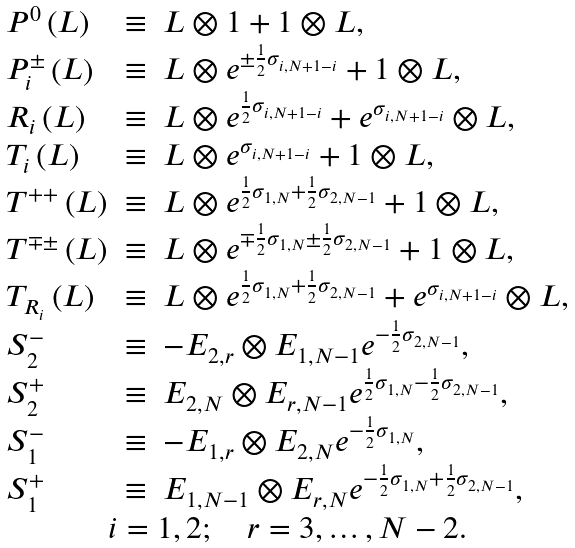Convert formula to latex. <formula><loc_0><loc_0><loc_500><loc_500>\begin{array} { c } \begin{array} { l l l } P ^ { 0 } \left ( L \right ) & \equiv & L \otimes 1 + 1 \otimes L , \\ P _ { i } ^ { \pm } \left ( L \right ) & \equiv & L \otimes e ^ { \pm \frac { 1 } { 2 } \sigma _ { i , N + 1 - i } } + 1 \otimes L , \\ R _ { i } \left ( L \right ) & \equiv & L \otimes e ^ { \frac { 1 } { 2 } \sigma _ { i , N + 1 - i } } + e ^ { \sigma _ { i , N + 1 - i } } \otimes L , \\ T _ { i } \left ( L \right ) & \equiv & L \otimes e ^ { \sigma _ { i , N + 1 - i } } + 1 \otimes L , \\ T ^ { + + } \left ( L \right ) & \equiv & L \otimes e ^ { \frac { 1 } { 2 } \sigma _ { 1 , N } + \frac { 1 } { 2 } \sigma _ { 2 , N - 1 } } + 1 \otimes L , \\ T ^ { \mp \pm } \left ( L \right ) & \equiv & L \otimes e ^ { \mp \frac { 1 } { 2 } \sigma _ { 1 , N } \pm \frac { 1 } { 2 } \sigma _ { 2 , N - 1 } } + 1 \otimes L , \\ T _ { R _ { i } } \left ( L \right ) & \equiv & L \otimes e ^ { \frac { 1 } { 2 } \sigma _ { 1 , N } + \frac { 1 } { 2 } \sigma _ { 2 , N - 1 } } + e ^ { \sigma _ { i , N + 1 - i } } \otimes L , \\ S _ { 2 } ^ { - } & \equiv & - E _ { 2 , r } \otimes E _ { 1 , N - 1 } e ^ { - \frac { 1 } { 2 } \sigma _ { 2 , N - 1 } } , \\ S _ { 2 } ^ { + } & \equiv & E _ { 2 , N } \otimes E _ { r , N - 1 } e ^ { \frac { 1 } { 2 } \sigma _ { 1 , N } - \frac { 1 } { 2 } \sigma _ { 2 , N - 1 } } , \\ S _ { 1 } ^ { - } & \equiv & - E _ { 1 , r } \otimes E _ { 2 , N } e ^ { - \frac { 1 } { 2 } \sigma _ { 1 , N } } , \\ S _ { 1 } ^ { + } & \equiv & E _ { 1 , N - 1 } \otimes E _ { r , N } e ^ { - \frac { 1 } { 2 } \sigma _ { 1 , N } + \frac { 1 } { 2 } \sigma _ { 2 , N - 1 } } , \end{array} \\ i = 1 , 2 ; \quad r = 3 , \dots , N - 2 . \end{array}</formula> 